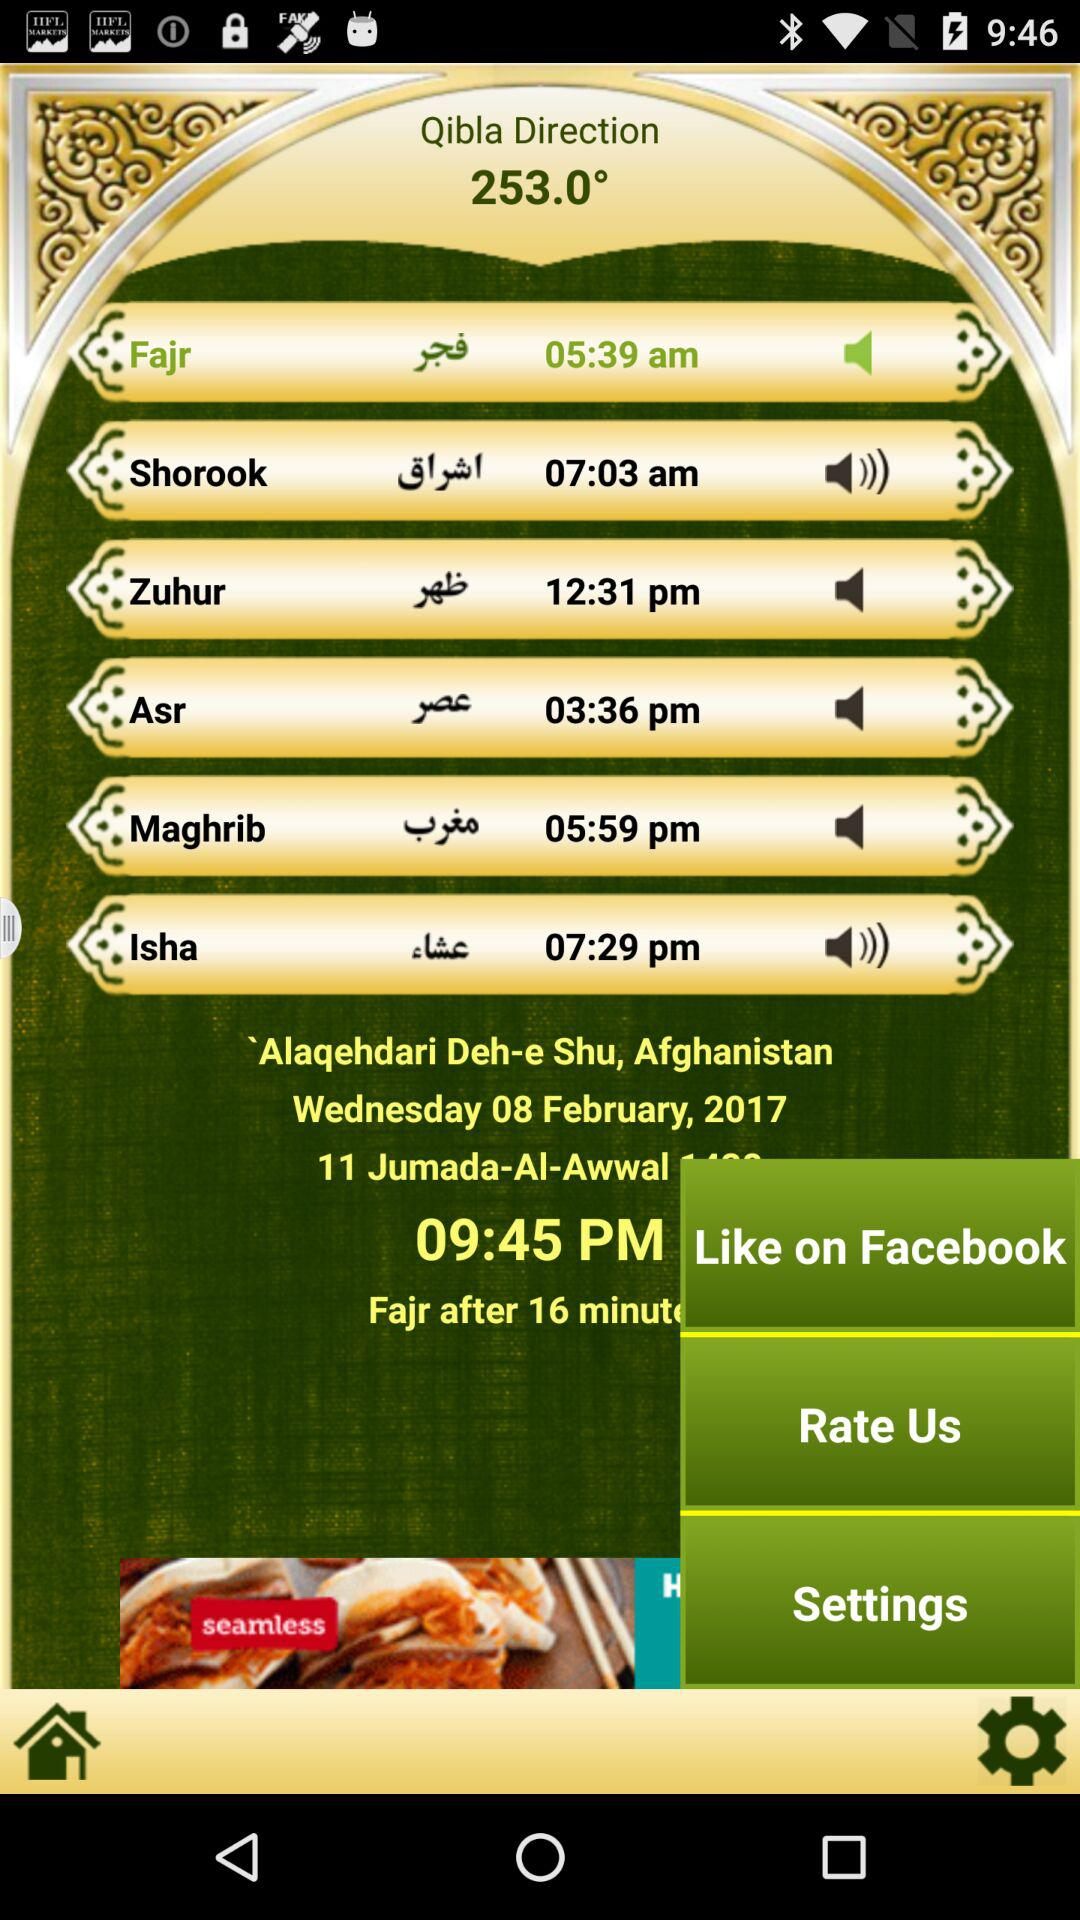What is the time for "Fajr"? The time for "Fajr" is 05:39 am. 